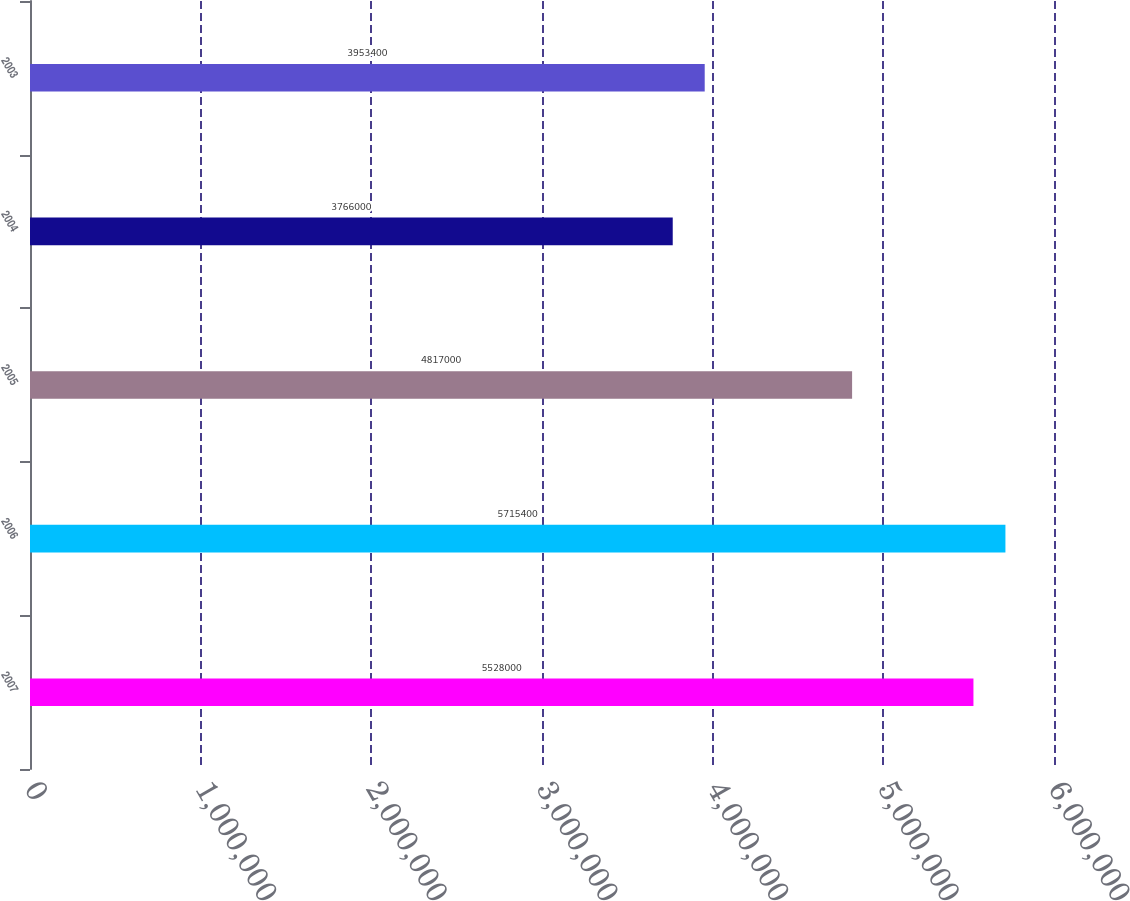Convert chart. <chart><loc_0><loc_0><loc_500><loc_500><bar_chart><fcel>2007<fcel>2006<fcel>2005<fcel>2004<fcel>2003<nl><fcel>5.528e+06<fcel>5.7154e+06<fcel>4.817e+06<fcel>3.766e+06<fcel>3.9534e+06<nl></chart> 